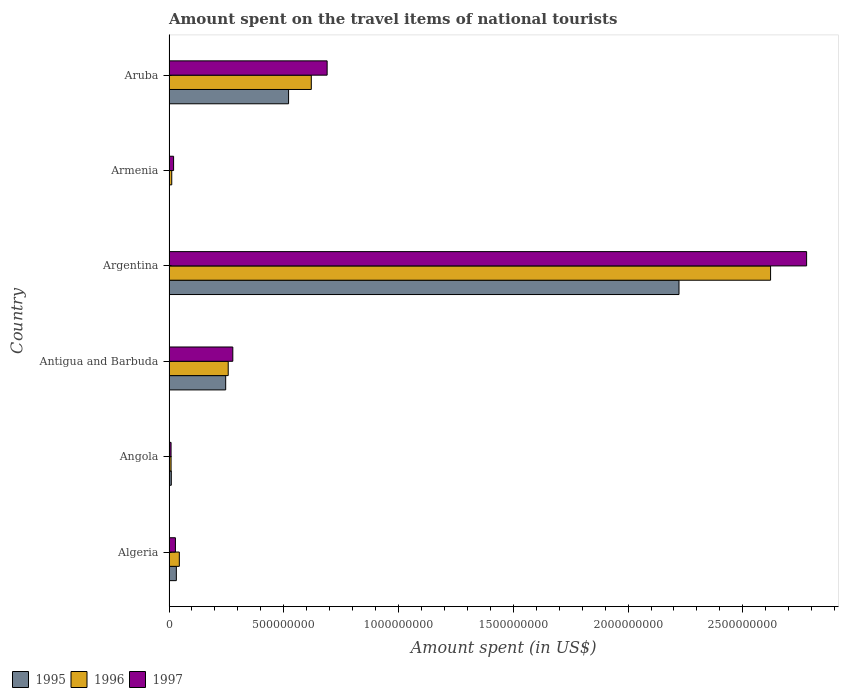How many different coloured bars are there?
Provide a short and direct response. 3. What is the label of the 2nd group of bars from the top?
Your response must be concise. Armenia. In how many cases, is the number of bars for a given country not equal to the number of legend labels?
Your answer should be very brief. 0. What is the amount spent on the travel items of national tourists in 1995 in Angola?
Make the answer very short. 1.00e+07. Across all countries, what is the maximum amount spent on the travel items of national tourists in 1997?
Your response must be concise. 2.78e+09. In which country was the amount spent on the travel items of national tourists in 1997 maximum?
Provide a short and direct response. Argentina. In which country was the amount spent on the travel items of national tourists in 1997 minimum?
Provide a succinct answer. Angola. What is the total amount spent on the travel items of national tourists in 1995 in the graph?
Keep it short and to the point. 3.03e+09. What is the difference between the amount spent on the travel items of national tourists in 1996 in Angola and that in Aruba?
Offer a terse response. -6.11e+08. What is the difference between the amount spent on the travel items of national tourists in 1996 in Aruba and the amount spent on the travel items of national tourists in 1997 in Armenia?
Provide a succinct answer. 6.00e+08. What is the average amount spent on the travel items of national tourists in 1997 per country?
Provide a succinct answer. 6.34e+08. What is the difference between the amount spent on the travel items of national tourists in 1995 and amount spent on the travel items of national tourists in 1997 in Armenia?
Provide a short and direct response. -1.90e+07. In how many countries, is the amount spent on the travel items of national tourists in 1997 greater than 2500000000 US$?
Offer a very short reply. 1. What is the ratio of the amount spent on the travel items of national tourists in 1996 in Antigua and Barbuda to that in Argentina?
Provide a succinct answer. 0.1. Is the amount spent on the travel items of national tourists in 1997 in Armenia less than that in Aruba?
Your answer should be compact. Yes. Is the difference between the amount spent on the travel items of national tourists in 1995 in Angola and Armenia greater than the difference between the amount spent on the travel items of national tourists in 1997 in Angola and Armenia?
Ensure brevity in your answer.  Yes. What is the difference between the highest and the second highest amount spent on the travel items of national tourists in 1997?
Provide a succinct answer. 2.09e+09. What is the difference between the highest and the lowest amount spent on the travel items of national tourists in 1997?
Make the answer very short. 2.77e+09. In how many countries, is the amount spent on the travel items of national tourists in 1995 greater than the average amount spent on the travel items of national tourists in 1995 taken over all countries?
Offer a very short reply. 2. Is the sum of the amount spent on the travel items of national tourists in 1997 in Argentina and Aruba greater than the maximum amount spent on the travel items of national tourists in 1996 across all countries?
Make the answer very short. Yes. What does the 3rd bar from the top in Algeria represents?
Provide a short and direct response. 1995. What does the 3rd bar from the bottom in Angola represents?
Your answer should be compact. 1997. How many bars are there?
Keep it short and to the point. 18. Are all the bars in the graph horizontal?
Provide a succinct answer. Yes. How many countries are there in the graph?
Provide a succinct answer. 6. Does the graph contain any zero values?
Your answer should be very brief. No. Where does the legend appear in the graph?
Your answer should be compact. Bottom left. How are the legend labels stacked?
Your answer should be compact. Horizontal. What is the title of the graph?
Your answer should be compact. Amount spent on the travel items of national tourists. Does "1961" appear as one of the legend labels in the graph?
Offer a terse response. No. What is the label or title of the X-axis?
Your answer should be very brief. Amount spent (in US$). What is the Amount spent (in US$) in 1995 in Algeria?
Make the answer very short. 3.20e+07. What is the Amount spent (in US$) in 1996 in Algeria?
Your response must be concise. 4.50e+07. What is the Amount spent (in US$) of 1997 in Algeria?
Your answer should be very brief. 2.80e+07. What is the Amount spent (in US$) of 1996 in Angola?
Offer a terse response. 9.00e+06. What is the Amount spent (in US$) of 1997 in Angola?
Make the answer very short. 9.00e+06. What is the Amount spent (in US$) of 1995 in Antigua and Barbuda?
Offer a terse response. 2.47e+08. What is the Amount spent (in US$) of 1996 in Antigua and Barbuda?
Your answer should be compact. 2.58e+08. What is the Amount spent (in US$) in 1997 in Antigua and Barbuda?
Your answer should be very brief. 2.78e+08. What is the Amount spent (in US$) in 1995 in Argentina?
Make the answer very short. 2.22e+09. What is the Amount spent (in US$) in 1996 in Argentina?
Your response must be concise. 2.62e+09. What is the Amount spent (in US$) in 1997 in Argentina?
Your response must be concise. 2.78e+09. What is the Amount spent (in US$) in 1996 in Armenia?
Offer a very short reply. 1.20e+07. What is the Amount spent (in US$) of 1997 in Armenia?
Offer a very short reply. 2.00e+07. What is the Amount spent (in US$) of 1995 in Aruba?
Give a very brief answer. 5.21e+08. What is the Amount spent (in US$) in 1996 in Aruba?
Make the answer very short. 6.20e+08. What is the Amount spent (in US$) in 1997 in Aruba?
Your response must be concise. 6.89e+08. Across all countries, what is the maximum Amount spent (in US$) in 1995?
Offer a terse response. 2.22e+09. Across all countries, what is the maximum Amount spent (in US$) of 1996?
Your response must be concise. 2.62e+09. Across all countries, what is the maximum Amount spent (in US$) in 1997?
Offer a very short reply. 2.78e+09. Across all countries, what is the minimum Amount spent (in US$) in 1995?
Make the answer very short. 1.00e+06. Across all countries, what is the minimum Amount spent (in US$) of 1996?
Offer a terse response. 9.00e+06. Across all countries, what is the minimum Amount spent (in US$) in 1997?
Make the answer very short. 9.00e+06. What is the total Amount spent (in US$) of 1995 in the graph?
Provide a succinct answer. 3.03e+09. What is the total Amount spent (in US$) in 1996 in the graph?
Make the answer very short. 3.56e+09. What is the total Amount spent (in US$) in 1997 in the graph?
Ensure brevity in your answer.  3.80e+09. What is the difference between the Amount spent (in US$) of 1995 in Algeria and that in Angola?
Your response must be concise. 2.20e+07. What is the difference between the Amount spent (in US$) of 1996 in Algeria and that in Angola?
Offer a terse response. 3.60e+07. What is the difference between the Amount spent (in US$) in 1997 in Algeria and that in Angola?
Offer a terse response. 1.90e+07. What is the difference between the Amount spent (in US$) of 1995 in Algeria and that in Antigua and Barbuda?
Provide a succinct answer. -2.15e+08. What is the difference between the Amount spent (in US$) of 1996 in Algeria and that in Antigua and Barbuda?
Your answer should be compact. -2.13e+08. What is the difference between the Amount spent (in US$) in 1997 in Algeria and that in Antigua and Barbuda?
Your answer should be compact. -2.50e+08. What is the difference between the Amount spent (in US$) in 1995 in Algeria and that in Argentina?
Give a very brief answer. -2.19e+09. What is the difference between the Amount spent (in US$) of 1996 in Algeria and that in Argentina?
Give a very brief answer. -2.58e+09. What is the difference between the Amount spent (in US$) in 1997 in Algeria and that in Argentina?
Keep it short and to the point. -2.75e+09. What is the difference between the Amount spent (in US$) of 1995 in Algeria and that in Armenia?
Your response must be concise. 3.10e+07. What is the difference between the Amount spent (in US$) in 1996 in Algeria and that in Armenia?
Your answer should be very brief. 3.30e+07. What is the difference between the Amount spent (in US$) in 1997 in Algeria and that in Armenia?
Offer a very short reply. 8.00e+06. What is the difference between the Amount spent (in US$) of 1995 in Algeria and that in Aruba?
Your answer should be very brief. -4.89e+08. What is the difference between the Amount spent (in US$) in 1996 in Algeria and that in Aruba?
Your answer should be very brief. -5.75e+08. What is the difference between the Amount spent (in US$) of 1997 in Algeria and that in Aruba?
Give a very brief answer. -6.61e+08. What is the difference between the Amount spent (in US$) of 1995 in Angola and that in Antigua and Barbuda?
Give a very brief answer. -2.37e+08. What is the difference between the Amount spent (in US$) in 1996 in Angola and that in Antigua and Barbuda?
Offer a terse response. -2.49e+08. What is the difference between the Amount spent (in US$) of 1997 in Angola and that in Antigua and Barbuda?
Make the answer very short. -2.69e+08. What is the difference between the Amount spent (in US$) in 1995 in Angola and that in Argentina?
Provide a succinct answer. -2.21e+09. What is the difference between the Amount spent (in US$) in 1996 in Angola and that in Argentina?
Make the answer very short. -2.61e+09. What is the difference between the Amount spent (in US$) in 1997 in Angola and that in Argentina?
Provide a short and direct response. -2.77e+09. What is the difference between the Amount spent (in US$) of 1995 in Angola and that in Armenia?
Your answer should be very brief. 9.00e+06. What is the difference between the Amount spent (in US$) of 1996 in Angola and that in Armenia?
Your answer should be very brief. -3.00e+06. What is the difference between the Amount spent (in US$) in 1997 in Angola and that in Armenia?
Offer a terse response. -1.10e+07. What is the difference between the Amount spent (in US$) in 1995 in Angola and that in Aruba?
Make the answer very short. -5.11e+08. What is the difference between the Amount spent (in US$) in 1996 in Angola and that in Aruba?
Keep it short and to the point. -6.11e+08. What is the difference between the Amount spent (in US$) in 1997 in Angola and that in Aruba?
Ensure brevity in your answer.  -6.80e+08. What is the difference between the Amount spent (in US$) of 1995 in Antigua and Barbuda and that in Argentina?
Make the answer very short. -1.98e+09. What is the difference between the Amount spent (in US$) in 1996 in Antigua and Barbuda and that in Argentina?
Your answer should be compact. -2.36e+09. What is the difference between the Amount spent (in US$) in 1997 in Antigua and Barbuda and that in Argentina?
Make the answer very short. -2.50e+09. What is the difference between the Amount spent (in US$) in 1995 in Antigua and Barbuda and that in Armenia?
Provide a succinct answer. 2.46e+08. What is the difference between the Amount spent (in US$) in 1996 in Antigua and Barbuda and that in Armenia?
Give a very brief answer. 2.46e+08. What is the difference between the Amount spent (in US$) in 1997 in Antigua and Barbuda and that in Armenia?
Provide a succinct answer. 2.58e+08. What is the difference between the Amount spent (in US$) of 1995 in Antigua and Barbuda and that in Aruba?
Your answer should be very brief. -2.74e+08. What is the difference between the Amount spent (in US$) of 1996 in Antigua and Barbuda and that in Aruba?
Make the answer very short. -3.62e+08. What is the difference between the Amount spent (in US$) in 1997 in Antigua and Barbuda and that in Aruba?
Keep it short and to the point. -4.11e+08. What is the difference between the Amount spent (in US$) of 1995 in Argentina and that in Armenia?
Your response must be concise. 2.22e+09. What is the difference between the Amount spent (in US$) of 1996 in Argentina and that in Armenia?
Offer a very short reply. 2.61e+09. What is the difference between the Amount spent (in US$) in 1997 in Argentina and that in Armenia?
Offer a terse response. 2.76e+09. What is the difference between the Amount spent (in US$) in 1995 in Argentina and that in Aruba?
Your answer should be very brief. 1.70e+09. What is the difference between the Amount spent (in US$) of 1996 in Argentina and that in Aruba?
Your response must be concise. 2.00e+09. What is the difference between the Amount spent (in US$) of 1997 in Argentina and that in Aruba?
Keep it short and to the point. 2.09e+09. What is the difference between the Amount spent (in US$) of 1995 in Armenia and that in Aruba?
Provide a short and direct response. -5.20e+08. What is the difference between the Amount spent (in US$) of 1996 in Armenia and that in Aruba?
Provide a succinct answer. -6.08e+08. What is the difference between the Amount spent (in US$) in 1997 in Armenia and that in Aruba?
Provide a short and direct response. -6.69e+08. What is the difference between the Amount spent (in US$) in 1995 in Algeria and the Amount spent (in US$) in 1996 in Angola?
Your answer should be very brief. 2.30e+07. What is the difference between the Amount spent (in US$) of 1995 in Algeria and the Amount spent (in US$) of 1997 in Angola?
Provide a succinct answer. 2.30e+07. What is the difference between the Amount spent (in US$) of 1996 in Algeria and the Amount spent (in US$) of 1997 in Angola?
Your response must be concise. 3.60e+07. What is the difference between the Amount spent (in US$) in 1995 in Algeria and the Amount spent (in US$) in 1996 in Antigua and Barbuda?
Ensure brevity in your answer.  -2.26e+08. What is the difference between the Amount spent (in US$) in 1995 in Algeria and the Amount spent (in US$) in 1997 in Antigua and Barbuda?
Your response must be concise. -2.46e+08. What is the difference between the Amount spent (in US$) in 1996 in Algeria and the Amount spent (in US$) in 1997 in Antigua and Barbuda?
Your response must be concise. -2.33e+08. What is the difference between the Amount spent (in US$) in 1995 in Algeria and the Amount spent (in US$) in 1996 in Argentina?
Make the answer very short. -2.59e+09. What is the difference between the Amount spent (in US$) of 1995 in Algeria and the Amount spent (in US$) of 1997 in Argentina?
Make the answer very short. -2.75e+09. What is the difference between the Amount spent (in US$) of 1996 in Algeria and the Amount spent (in US$) of 1997 in Argentina?
Your response must be concise. -2.73e+09. What is the difference between the Amount spent (in US$) in 1995 in Algeria and the Amount spent (in US$) in 1996 in Armenia?
Keep it short and to the point. 2.00e+07. What is the difference between the Amount spent (in US$) of 1995 in Algeria and the Amount spent (in US$) of 1997 in Armenia?
Your answer should be compact. 1.20e+07. What is the difference between the Amount spent (in US$) in 1996 in Algeria and the Amount spent (in US$) in 1997 in Armenia?
Keep it short and to the point. 2.50e+07. What is the difference between the Amount spent (in US$) of 1995 in Algeria and the Amount spent (in US$) of 1996 in Aruba?
Offer a very short reply. -5.88e+08. What is the difference between the Amount spent (in US$) in 1995 in Algeria and the Amount spent (in US$) in 1997 in Aruba?
Provide a short and direct response. -6.57e+08. What is the difference between the Amount spent (in US$) of 1996 in Algeria and the Amount spent (in US$) of 1997 in Aruba?
Your answer should be compact. -6.44e+08. What is the difference between the Amount spent (in US$) in 1995 in Angola and the Amount spent (in US$) in 1996 in Antigua and Barbuda?
Offer a very short reply. -2.48e+08. What is the difference between the Amount spent (in US$) in 1995 in Angola and the Amount spent (in US$) in 1997 in Antigua and Barbuda?
Your answer should be very brief. -2.68e+08. What is the difference between the Amount spent (in US$) in 1996 in Angola and the Amount spent (in US$) in 1997 in Antigua and Barbuda?
Provide a short and direct response. -2.69e+08. What is the difference between the Amount spent (in US$) of 1995 in Angola and the Amount spent (in US$) of 1996 in Argentina?
Give a very brief answer. -2.61e+09. What is the difference between the Amount spent (in US$) in 1995 in Angola and the Amount spent (in US$) in 1997 in Argentina?
Your response must be concise. -2.77e+09. What is the difference between the Amount spent (in US$) in 1996 in Angola and the Amount spent (in US$) in 1997 in Argentina?
Give a very brief answer. -2.77e+09. What is the difference between the Amount spent (in US$) in 1995 in Angola and the Amount spent (in US$) in 1996 in Armenia?
Provide a succinct answer. -2.00e+06. What is the difference between the Amount spent (in US$) in 1995 in Angola and the Amount spent (in US$) in 1997 in Armenia?
Your answer should be very brief. -1.00e+07. What is the difference between the Amount spent (in US$) of 1996 in Angola and the Amount spent (in US$) of 1997 in Armenia?
Give a very brief answer. -1.10e+07. What is the difference between the Amount spent (in US$) in 1995 in Angola and the Amount spent (in US$) in 1996 in Aruba?
Your response must be concise. -6.10e+08. What is the difference between the Amount spent (in US$) in 1995 in Angola and the Amount spent (in US$) in 1997 in Aruba?
Ensure brevity in your answer.  -6.79e+08. What is the difference between the Amount spent (in US$) in 1996 in Angola and the Amount spent (in US$) in 1997 in Aruba?
Offer a terse response. -6.80e+08. What is the difference between the Amount spent (in US$) of 1995 in Antigua and Barbuda and the Amount spent (in US$) of 1996 in Argentina?
Provide a short and direct response. -2.37e+09. What is the difference between the Amount spent (in US$) of 1995 in Antigua and Barbuda and the Amount spent (in US$) of 1997 in Argentina?
Give a very brief answer. -2.53e+09. What is the difference between the Amount spent (in US$) in 1996 in Antigua and Barbuda and the Amount spent (in US$) in 1997 in Argentina?
Your answer should be very brief. -2.52e+09. What is the difference between the Amount spent (in US$) of 1995 in Antigua and Barbuda and the Amount spent (in US$) of 1996 in Armenia?
Your response must be concise. 2.35e+08. What is the difference between the Amount spent (in US$) of 1995 in Antigua and Barbuda and the Amount spent (in US$) of 1997 in Armenia?
Your response must be concise. 2.27e+08. What is the difference between the Amount spent (in US$) of 1996 in Antigua and Barbuda and the Amount spent (in US$) of 1997 in Armenia?
Offer a very short reply. 2.38e+08. What is the difference between the Amount spent (in US$) of 1995 in Antigua and Barbuda and the Amount spent (in US$) of 1996 in Aruba?
Your answer should be very brief. -3.73e+08. What is the difference between the Amount spent (in US$) of 1995 in Antigua and Barbuda and the Amount spent (in US$) of 1997 in Aruba?
Keep it short and to the point. -4.42e+08. What is the difference between the Amount spent (in US$) in 1996 in Antigua and Barbuda and the Amount spent (in US$) in 1997 in Aruba?
Offer a terse response. -4.31e+08. What is the difference between the Amount spent (in US$) in 1995 in Argentina and the Amount spent (in US$) in 1996 in Armenia?
Offer a terse response. 2.21e+09. What is the difference between the Amount spent (in US$) of 1995 in Argentina and the Amount spent (in US$) of 1997 in Armenia?
Your answer should be very brief. 2.20e+09. What is the difference between the Amount spent (in US$) of 1996 in Argentina and the Amount spent (in US$) of 1997 in Armenia?
Provide a succinct answer. 2.60e+09. What is the difference between the Amount spent (in US$) of 1995 in Argentina and the Amount spent (in US$) of 1996 in Aruba?
Ensure brevity in your answer.  1.60e+09. What is the difference between the Amount spent (in US$) in 1995 in Argentina and the Amount spent (in US$) in 1997 in Aruba?
Provide a succinct answer. 1.53e+09. What is the difference between the Amount spent (in US$) in 1996 in Argentina and the Amount spent (in US$) in 1997 in Aruba?
Keep it short and to the point. 1.93e+09. What is the difference between the Amount spent (in US$) in 1995 in Armenia and the Amount spent (in US$) in 1996 in Aruba?
Your answer should be compact. -6.19e+08. What is the difference between the Amount spent (in US$) of 1995 in Armenia and the Amount spent (in US$) of 1997 in Aruba?
Offer a terse response. -6.88e+08. What is the difference between the Amount spent (in US$) of 1996 in Armenia and the Amount spent (in US$) of 1997 in Aruba?
Provide a succinct answer. -6.77e+08. What is the average Amount spent (in US$) in 1995 per country?
Give a very brief answer. 5.06e+08. What is the average Amount spent (in US$) in 1996 per country?
Give a very brief answer. 5.94e+08. What is the average Amount spent (in US$) of 1997 per country?
Provide a succinct answer. 6.34e+08. What is the difference between the Amount spent (in US$) of 1995 and Amount spent (in US$) of 1996 in Algeria?
Give a very brief answer. -1.30e+07. What is the difference between the Amount spent (in US$) of 1996 and Amount spent (in US$) of 1997 in Algeria?
Keep it short and to the point. 1.70e+07. What is the difference between the Amount spent (in US$) in 1995 and Amount spent (in US$) in 1996 in Angola?
Offer a very short reply. 1.00e+06. What is the difference between the Amount spent (in US$) in 1995 and Amount spent (in US$) in 1996 in Antigua and Barbuda?
Provide a short and direct response. -1.10e+07. What is the difference between the Amount spent (in US$) in 1995 and Amount spent (in US$) in 1997 in Antigua and Barbuda?
Provide a short and direct response. -3.10e+07. What is the difference between the Amount spent (in US$) of 1996 and Amount spent (in US$) of 1997 in Antigua and Barbuda?
Offer a very short reply. -2.00e+07. What is the difference between the Amount spent (in US$) of 1995 and Amount spent (in US$) of 1996 in Argentina?
Your answer should be very brief. -3.99e+08. What is the difference between the Amount spent (in US$) in 1995 and Amount spent (in US$) in 1997 in Argentina?
Your answer should be compact. -5.56e+08. What is the difference between the Amount spent (in US$) in 1996 and Amount spent (in US$) in 1997 in Argentina?
Offer a terse response. -1.57e+08. What is the difference between the Amount spent (in US$) of 1995 and Amount spent (in US$) of 1996 in Armenia?
Your response must be concise. -1.10e+07. What is the difference between the Amount spent (in US$) in 1995 and Amount spent (in US$) in 1997 in Armenia?
Ensure brevity in your answer.  -1.90e+07. What is the difference between the Amount spent (in US$) of 1996 and Amount spent (in US$) of 1997 in Armenia?
Offer a very short reply. -8.00e+06. What is the difference between the Amount spent (in US$) of 1995 and Amount spent (in US$) of 1996 in Aruba?
Make the answer very short. -9.90e+07. What is the difference between the Amount spent (in US$) in 1995 and Amount spent (in US$) in 1997 in Aruba?
Offer a very short reply. -1.68e+08. What is the difference between the Amount spent (in US$) of 1996 and Amount spent (in US$) of 1997 in Aruba?
Your answer should be compact. -6.90e+07. What is the ratio of the Amount spent (in US$) in 1995 in Algeria to that in Angola?
Ensure brevity in your answer.  3.2. What is the ratio of the Amount spent (in US$) of 1996 in Algeria to that in Angola?
Your answer should be compact. 5. What is the ratio of the Amount spent (in US$) in 1997 in Algeria to that in Angola?
Offer a terse response. 3.11. What is the ratio of the Amount spent (in US$) of 1995 in Algeria to that in Antigua and Barbuda?
Provide a succinct answer. 0.13. What is the ratio of the Amount spent (in US$) of 1996 in Algeria to that in Antigua and Barbuda?
Give a very brief answer. 0.17. What is the ratio of the Amount spent (in US$) in 1997 in Algeria to that in Antigua and Barbuda?
Give a very brief answer. 0.1. What is the ratio of the Amount spent (in US$) in 1995 in Algeria to that in Argentina?
Give a very brief answer. 0.01. What is the ratio of the Amount spent (in US$) of 1996 in Algeria to that in Argentina?
Ensure brevity in your answer.  0.02. What is the ratio of the Amount spent (in US$) of 1997 in Algeria to that in Argentina?
Ensure brevity in your answer.  0.01. What is the ratio of the Amount spent (in US$) in 1995 in Algeria to that in Armenia?
Give a very brief answer. 32. What is the ratio of the Amount spent (in US$) in 1996 in Algeria to that in Armenia?
Your answer should be very brief. 3.75. What is the ratio of the Amount spent (in US$) in 1997 in Algeria to that in Armenia?
Offer a terse response. 1.4. What is the ratio of the Amount spent (in US$) in 1995 in Algeria to that in Aruba?
Your response must be concise. 0.06. What is the ratio of the Amount spent (in US$) of 1996 in Algeria to that in Aruba?
Provide a succinct answer. 0.07. What is the ratio of the Amount spent (in US$) in 1997 in Algeria to that in Aruba?
Your answer should be compact. 0.04. What is the ratio of the Amount spent (in US$) in 1995 in Angola to that in Antigua and Barbuda?
Make the answer very short. 0.04. What is the ratio of the Amount spent (in US$) in 1996 in Angola to that in Antigua and Barbuda?
Your answer should be compact. 0.03. What is the ratio of the Amount spent (in US$) of 1997 in Angola to that in Antigua and Barbuda?
Offer a very short reply. 0.03. What is the ratio of the Amount spent (in US$) of 1995 in Angola to that in Argentina?
Keep it short and to the point. 0. What is the ratio of the Amount spent (in US$) in 1996 in Angola to that in Argentina?
Your answer should be compact. 0. What is the ratio of the Amount spent (in US$) in 1997 in Angola to that in Argentina?
Offer a very short reply. 0. What is the ratio of the Amount spent (in US$) in 1995 in Angola to that in Armenia?
Keep it short and to the point. 10. What is the ratio of the Amount spent (in US$) in 1996 in Angola to that in Armenia?
Offer a very short reply. 0.75. What is the ratio of the Amount spent (in US$) in 1997 in Angola to that in Armenia?
Your answer should be compact. 0.45. What is the ratio of the Amount spent (in US$) in 1995 in Angola to that in Aruba?
Your answer should be very brief. 0.02. What is the ratio of the Amount spent (in US$) of 1996 in Angola to that in Aruba?
Give a very brief answer. 0.01. What is the ratio of the Amount spent (in US$) in 1997 in Angola to that in Aruba?
Keep it short and to the point. 0.01. What is the ratio of the Amount spent (in US$) in 1995 in Antigua and Barbuda to that in Argentina?
Keep it short and to the point. 0.11. What is the ratio of the Amount spent (in US$) of 1996 in Antigua and Barbuda to that in Argentina?
Provide a succinct answer. 0.1. What is the ratio of the Amount spent (in US$) of 1997 in Antigua and Barbuda to that in Argentina?
Offer a very short reply. 0.1. What is the ratio of the Amount spent (in US$) of 1995 in Antigua and Barbuda to that in Armenia?
Keep it short and to the point. 247. What is the ratio of the Amount spent (in US$) of 1996 in Antigua and Barbuda to that in Armenia?
Make the answer very short. 21.5. What is the ratio of the Amount spent (in US$) of 1995 in Antigua and Barbuda to that in Aruba?
Your response must be concise. 0.47. What is the ratio of the Amount spent (in US$) in 1996 in Antigua and Barbuda to that in Aruba?
Give a very brief answer. 0.42. What is the ratio of the Amount spent (in US$) in 1997 in Antigua and Barbuda to that in Aruba?
Your answer should be very brief. 0.4. What is the ratio of the Amount spent (in US$) of 1995 in Argentina to that in Armenia?
Your response must be concise. 2222. What is the ratio of the Amount spent (in US$) of 1996 in Argentina to that in Armenia?
Your answer should be compact. 218.42. What is the ratio of the Amount spent (in US$) of 1997 in Argentina to that in Armenia?
Your response must be concise. 138.9. What is the ratio of the Amount spent (in US$) in 1995 in Argentina to that in Aruba?
Provide a succinct answer. 4.26. What is the ratio of the Amount spent (in US$) of 1996 in Argentina to that in Aruba?
Offer a very short reply. 4.23. What is the ratio of the Amount spent (in US$) of 1997 in Argentina to that in Aruba?
Keep it short and to the point. 4.03. What is the ratio of the Amount spent (in US$) of 1995 in Armenia to that in Aruba?
Provide a succinct answer. 0. What is the ratio of the Amount spent (in US$) of 1996 in Armenia to that in Aruba?
Give a very brief answer. 0.02. What is the ratio of the Amount spent (in US$) of 1997 in Armenia to that in Aruba?
Provide a short and direct response. 0.03. What is the difference between the highest and the second highest Amount spent (in US$) of 1995?
Ensure brevity in your answer.  1.70e+09. What is the difference between the highest and the second highest Amount spent (in US$) in 1996?
Make the answer very short. 2.00e+09. What is the difference between the highest and the second highest Amount spent (in US$) in 1997?
Provide a short and direct response. 2.09e+09. What is the difference between the highest and the lowest Amount spent (in US$) in 1995?
Give a very brief answer. 2.22e+09. What is the difference between the highest and the lowest Amount spent (in US$) in 1996?
Provide a short and direct response. 2.61e+09. What is the difference between the highest and the lowest Amount spent (in US$) in 1997?
Your response must be concise. 2.77e+09. 